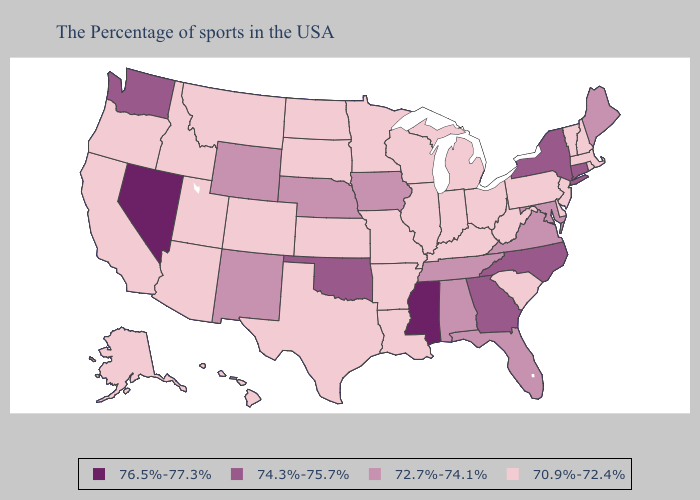Does Colorado have the lowest value in the USA?
Quick response, please. Yes. Does Maryland have the lowest value in the South?
Concise answer only. No. What is the highest value in states that border Indiana?
Write a very short answer. 70.9%-72.4%. What is the highest value in the South ?
Quick response, please. 76.5%-77.3%. Does Nebraska have the lowest value in the MidWest?
Concise answer only. No. Which states have the lowest value in the West?
Short answer required. Colorado, Utah, Montana, Arizona, Idaho, California, Oregon, Alaska, Hawaii. What is the value of Missouri?
Be succinct. 70.9%-72.4%. Name the states that have a value in the range 70.9%-72.4%?
Keep it brief. Massachusetts, Rhode Island, New Hampshire, Vermont, New Jersey, Delaware, Pennsylvania, South Carolina, West Virginia, Ohio, Michigan, Kentucky, Indiana, Wisconsin, Illinois, Louisiana, Missouri, Arkansas, Minnesota, Kansas, Texas, South Dakota, North Dakota, Colorado, Utah, Montana, Arizona, Idaho, California, Oregon, Alaska, Hawaii. Among the states that border Mississippi , does Tennessee have the lowest value?
Short answer required. No. Among the states that border Idaho , which have the highest value?
Concise answer only. Nevada. What is the value of Georgia?
Quick response, please. 74.3%-75.7%. Which states have the highest value in the USA?
Write a very short answer. Mississippi, Nevada. Name the states that have a value in the range 72.7%-74.1%?
Quick response, please. Maine, Maryland, Virginia, Florida, Alabama, Tennessee, Iowa, Nebraska, Wyoming, New Mexico. Among the states that border Missouri , which have the highest value?
Write a very short answer. Oklahoma. Among the states that border New Mexico , which have the lowest value?
Write a very short answer. Texas, Colorado, Utah, Arizona. 